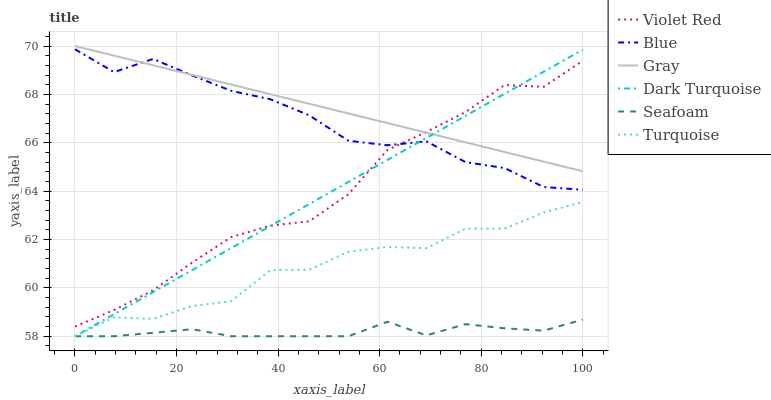Does Violet Red have the minimum area under the curve?
Answer yes or no. No. Does Violet Red have the maximum area under the curve?
Answer yes or no. No. Is Violet Red the smoothest?
Answer yes or no. No. Is Violet Red the roughest?
Answer yes or no. No. Does Violet Red have the lowest value?
Answer yes or no. No. Does Violet Red have the highest value?
Answer yes or no. No. Is Turquoise less than Gray?
Answer yes or no. Yes. Is Gray greater than Seafoam?
Answer yes or no. Yes. Does Turquoise intersect Gray?
Answer yes or no. No. 